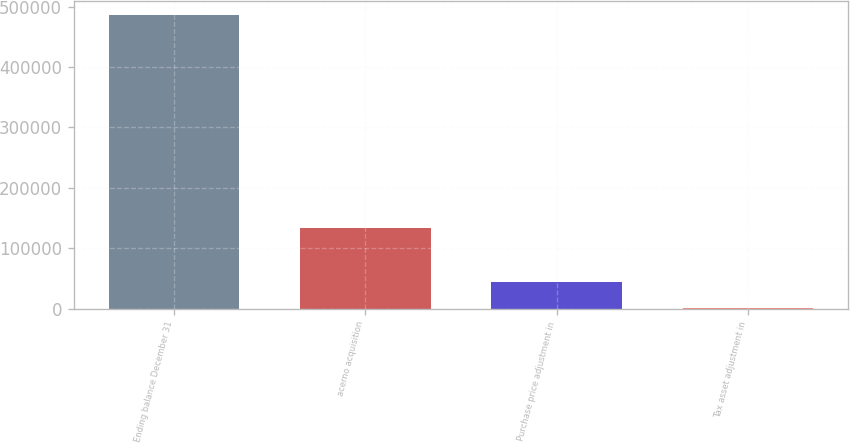<chart> <loc_0><loc_0><loc_500><loc_500><bar_chart><fcel>Ending balance December 31<fcel>acerno acquisition<fcel>Purchase price adjustment in<fcel>Tax asset adjustment in<nl><fcel>485340<fcel>132774<fcel>44609.9<fcel>528<nl></chart> 